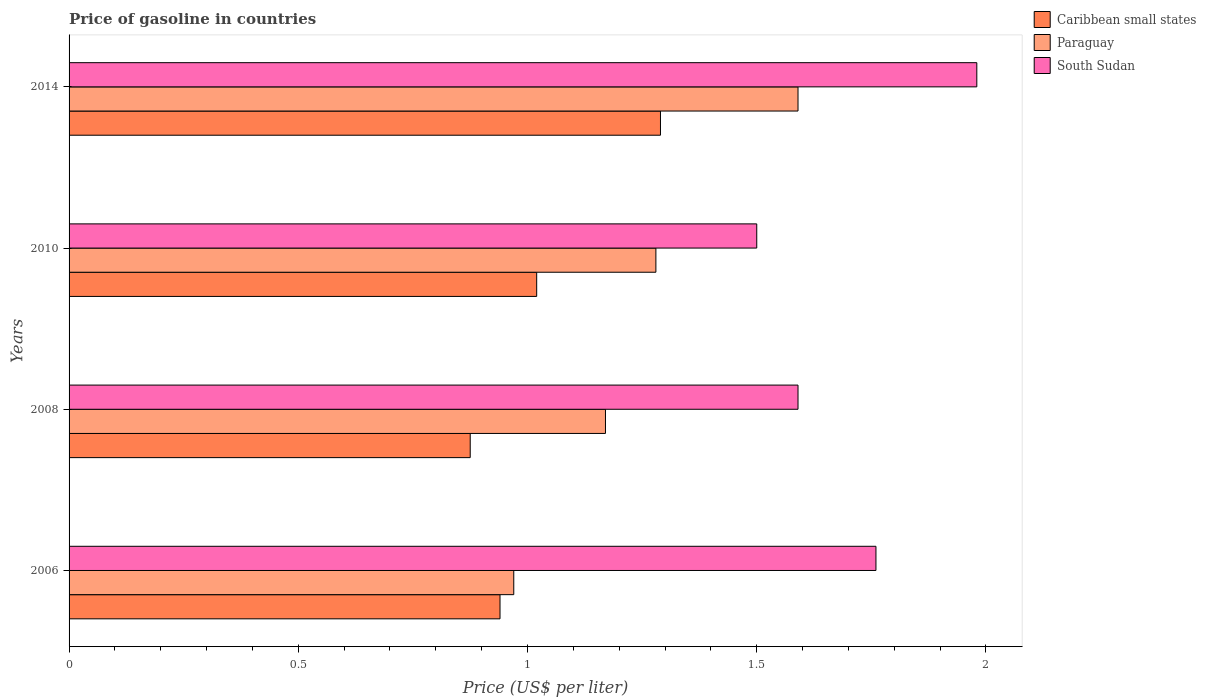How many groups of bars are there?
Give a very brief answer. 4. Are the number of bars on each tick of the Y-axis equal?
Keep it short and to the point. Yes. How many bars are there on the 2nd tick from the top?
Your answer should be very brief. 3. How many bars are there on the 1st tick from the bottom?
Your response must be concise. 3. In how many cases, is the number of bars for a given year not equal to the number of legend labels?
Give a very brief answer. 0. What is the price of gasoline in Paraguay in 2010?
Give a very brief answer. 1.28. Across all years, what is the maximum price of gasoline in South Sudan?
Provide a succinct answer. 1.98. What is the total price of gasoline in Paraguay in the graph?
Your answer should be compact. 5.01. What is the difference between the price of gasoline in South Sudan in 2008 and that in 2010?
Keep it short and to the point. 0.09. What is the difference between the price of gasoline in Caribbean small states in 2010 and the price of gasoline in Paraguay in 2014?
Your response must be concise. -0.57. What is the average price of gasoline in Caribbean small states per year?
Offer a terse response. 1.03. In the year 2006, what is the difference between the price of gasoline in South Sudan and price of gasoline in Caribbean small states?
Offer a very short reply. 0.82. What is the ratio of the price of gasoline in Paraguay in 2010 to that in 2014?
Your answer should be compact. 0.81. What is the difference between the highest and the second highest price of gasoline in South Sudan?
Offer a terse response. 0.22. What is the difference between the highest and the lowest price of gasoline in Caribbean small states?
Keep it short and to the point. 0.42. What does the 3rd bar from the top in 2008 represents?
Provide a short and direct response. Caribbean small states. What does the 1st bar from the bottom in 2006 represents?
Your answer should be compact. Caribbean small states. Is it the case that in every year, the sum of the price of gasoline in Caribbean small states and price of gasoline in South Sudan is greater than the price of gasoline in Paraguay?
Provide a short and direct response. Yes. How many years are there in the graph?
Keep it short and to the point. 4. Are the values on the major ticks of X-axis written in scientific E-notation?
Your response must be concise. No. Does the graph contain any zero values?
Make the answer very short. No. Where does the legend appear in the graph?
Your answer should be compact. Top right. What is the title of the graph?
Make the answer very short. Price of gasoline in countries. Does "Afghanistan" appear as one of the legend labels in the graph?
Provide a succinct answer. No. What is the label or title of the X-axis?
Provide a succinct answer. Price (US$ per liter). What is the label or title of the Y-axis?
Your response must be concise. Years. What is the Price (US$ per liter) of Caribbean small states in 2006?
Make the answer very short. 0.94. What is the Price (US$ per liter) of South Sudan in 2006?
Provide a succinct answer. 1.76. What is the Price (US$ per liter) in Paraguay in 2008?
Provide a succinct answer. 1.17. What is the Price (US$ per liter) in South Sudan in 2008?
Give a very brief answer. 1.59. What is the Price (US$ per liter) in Caribbean small states in 2010?
Your response must be concise. 1.02. What is the Price (US$ per liter) of Paraguay in 2010?
Your answer should be compact. 1.28. What is the Price (US$ per liter) of Caribbean small states in 2014?
Your answer should be very brief. 1.29. What is the Price (US$ per liter) of Paraguay in 2014?
Your answer should be very brief. 1.59. What is the Price (US$ per liter) of South Sudan in 2014?
Offer a terse response. 1.98. Across all years, what is the maximum Price (US$ per liter) of Caribbean small states?
Give a very brief answer. 1.29. Across all years, what is the maximum Price (US$ per liter) of Paraguay?
Offer a very short reply. 1.59. Across all years, what is the maximum Price (US$ per liter) of South Sudan?
Keep it short and to the point. 1.98. Across all years, what is the minimum Price (US$ per liter) of South Sudan?
Keep it short and to the point. 1.5. What is the total Price (US$ per liter) of Caribbean small states in the graph?
Your answer should be compact. 4.12. What is the total Price (US$ per liter) in Paraguay in the graph?
Keep it short and to the point. 5.01. What is the total Price (US$ per liter) of South Sudan in the graph?
Your answer should be compact. 6.83. What is the difference between the Price (US$ per liter) of Caribbean small states in 2006 and that in 2008?
Provide a short and direct response. 0.07. What is the difference between the Price (US$ per liter) of Paraguay in 2006 and that in 2008?
Provide a short and direct response. -0.2. What is the difference between the Price (US$ per liter) of South Sudan in 2006 and that in 2008?
Provide a succinct answer. 0.17. What is the difference between the Price (US$ per liter) in Caribbean small states in 2006 and that in 2010?
Offer a terse response. -0.08. What is the difference between the Price (US$ per liter) in Paraguay in 2006 and that in 2010?
Your response must be concise. -0.31. What is the difference between the Price (US$ per liter) in South Sudan in 2006 and that in 2010?
Keep it short and to the point. 0.26. What is the difference between the Price (US$ per liter) in Caribbean small states in 2006 and that in 2014?
Offer a very short reply. -0.35. What is the difference between the Price (US$ per liter) in Paraguay in 2006 and that in 2014?
Provide a succinct answer. -0.62. What is the difference between the Price (US$ per liter) in South Sudan in 2006 and that in 2014?
Offer a very short reply. -0.22. What is the difference between the Price (US$ per liter) in Caribbean small states in 2008 and that in 2010?
Make the answer very short. -0.14. What is the difference between the Price (US$ per liter) in Paraguay in 2008 and that in 2010?
Make the answer very short. -0.11. What is the difference between the Price (US$ per liter) of South Sudan in 2008 and that in 2010?
Provide a succinct answer. 0.09. What is the difference between the Price (US$ per liter) in Caribbean small states in 2008 and that in 2014?
Provide a succinct answer. -0.41. What is the difference between the Price (US$ per liter) of Paraguay in 2008 and that in 2014?
Ensure brevity in your answer.  -0.42. What is the difference between the Price (US$ per liter) of South Sudan in 2008 and that in 2014?
Ensure brevity in your answer.  -0.39. What is the difference between the Price (US$ per liter) of Caribbean small states in 2010 and that in 2014?
Offer a terse response. -0.27. What is the difference between the Price (US$ per liter) in Paraguay in 2010 and that in 2014?
Your answer should be compact. -0.31. What is the difference between the Price (US$ per liter) of South Sudan in 2010 and that in 2014?
Make the answer very short. -0.48. What is the difference between the Price (US$ per liter) of Caribbean small states in 2006 and the Price (US$ per liter) of Paraguay in 2008?
Keep it short and to the point. -0.23. What is the difference between the Price (US$ per liter) in Caribbean small states in 2006 and the Price (US$ per liter) in South Sudan in 2008?
Keep it short and to the point. -0.65. What is the difference between the Price (US$ per liter) of Paraguay in 2006 and the Price (US$ per liter) of South Sudan in 2008?
Keep it short and to the point. -0.62. What is the difference between the Price (US$ per liter) in Caribbean small states in 2006 and the Price (US$ per liter) in Paraguay in 2010?
Make the answer very short. -0.34. What is the difference between the Price (US$ per liter) of Caribbean small states in 2006 and the Price (US$ per liter) of South Sudan in 2010?
Your answer should be compact. -0.56. What is the difference between the Price (US$ per liter) in Paraguay in 2006 and the Price (US$ per liter) in South Sudan in 2010?
Your answer should be very brief. -0.53. What is the difference between the Price (US$ per liter) of Caribbean small states in 2006 and the Price (US$ per liter) of Paraguay in 2014?
Give a very brief answer. -0.65. What is the difference between the Price (US$ per liter) in Caribbean small states in 2006 and the Price (US$ per liter) in South Sudan in 2014?
Your answer should be compact. -1.04. What is the difference between the Price (US$ per liter) in Paraguay in 2006 and the Price (US$ per liter) in South Sudan in 2014?
Provide a succinct answer. -1.01. What is the difference between the Price (US$ per liter) in Caribbean small states in 2008 and the Price (US$ per liter) in Paraguay in 2010?
Offer a very short reply. -0.41. What is the difference between the Price (US$ per liter) in Caribbean small states in 2008 and the Price (US$ per liter) in South Sudan in 2010?
Ensure brevity in your answer.  -0.62. What is the difference between the Price (US$ per liter) of Paraguay in 2008 and the Price (US$ per liter) of South Sudan in 2010?
Provide a succinct answer. -0.33. What is the difference between the Price (US$ per liter) in Caribbean small states in 2008 and the Price (US$ per liter) in Paraguay in 2014?
Your answer should be compact. -0.71. What is the difference between the Price (US$ per liter) in Caribbean small states in 2008 and the Price (US$ per liter) in South Sudan in 2014?
Provide a short and direct response. -1.1. What is the difference between the Price (US$ per liter) in Paraguay in 2008 and the Price (US$ per liter) in South Sudan in 2014?
Offer a very short reply. -0.81. What is the difference between the Price (US$ per liter) in Caribbean small states in 2010 and the Price (US$ per liter) in Paraguay in 2014?
Your response must be concise. -0.57. What is the difference between the Price (US$ per liter) in Caribbean small states in 2010 and the Price (US$ per liter) in South Sudan in 2014?
Give a very brief answer. -0.96. What is the difference between the Price (US$ per liter) in Paraguay in 2010 and the Price (US$ per liter) in South Sudan in 2014?
Your answer should be compact. -0.7. What is the average Price (US$ per liter) of Caribbean small states per year?
Make the answer very short. 1.03. What is the average Price (US$ per liter) in Paraguay per year?
Provide a succinct answer. 1.25. What is the average Price (US$ per liter) of South Sudan per year?
Offer a very short reply. 1.71. In the year 2006, what is the difference between the Price (US$ per liter) in Caribbean small states and Price (US$ per liter) in Paraguay?
Offer a terse response. -0.03. In the year 2006, what is the difference between the Price (US$ per liter) of Caribbean small states and Price (US$ per liter) of South Sudan?
Make the answer very short. -0.82. In the year 2006, what is the difference between the Price (US$ per liter) in Paraguay and Price (US$ per liter) in South Sudan?
Give a very brief answer. -0.79. In the year 2008, what is the difference between the Price (US$ per liter) in Caribbean small states and Price (US$ per liter) in Paraguay?
Ensure brevity in your answer.  -0.29. In the year 2008, what is the difference between the Price (US$ per liter) of Caribbean small states and Price (US$ per liter) of South Sudan?
Offer a very short reply. -0.71. In the year 2008, what is the difference between the Price (US$ per liter) in Paraguay and Price (US$ per liter) in South Sudan?
Keep it short and to the point. -0.42. In the year 2010, what is the difference between the Price (US$ per liter) in Caribbean small states and Price (US$ per liter) in Paraguay?
Provide a succinct answer. -0.26. In the year 2010, what is the difference between the Price (US$ per liter) of Caribbean small states and Price (US$ per liter) of South Sudan?
Offer a terse response. -0.48. In the year 2010, what is the difference between the Price (US$ per liter) in Paraguay and Price (US$ per liter) in South Sudan?
Provide a succinct answer. -0.22. In the year 2014, what is the difference between the Price (US$ per liter) of Caribbean small states and Price (US$ per liter) of South Sudan?
Give a very brief answer. -0.69. In the year 2014, what is the difference between the Price (US$ per liter) in Paraguay and Price (US$ per liter) in South Sudan?
Provide a succinct answer. -0.39. What is the ratio of the Price (US$ per liter) in Caribbean small states in 2006 to that in 2008?
Provide a succinct answer. 1.07. What is the ratio of the Price (US$ per liter) in Paraguay in 2006 to that in 2008?
Offer a terse response. 0.83. What is the ratio of the Price (US$ per liter) of South Sudan in 2006 to that in 2008?
Your answer should be compact. 1.11. What is the ratio of the Price (US$ per liter) of Caribbean small states in 2006 to that in 2010?
Offer a very short reply. 0.92. What is the ratio of the Price (US$ per liter) of Paraguay in 2006 to that in 2010?
Make the answer very short. 0.76. What is the ratio of the Price (US$ per liter) of South Sudan in 2006 to that in 2010?
Give a very brief answer. 1.17. What is the ratio of the Price (US$ per liter) of Caribbean small states in 2006 to that in 2014?
Provide a short and direct response. 0.73. What is the ratio of the Price (US$ per liter) in Paraguay in 2006 to that in 2014?
Give a very brief answer. 0.61. What is the ratio of the Price (US$ per liter) in South Sudan in 2006 to that in 2014?
Give a very brief answer. 0.89. What is the ratio of the Price (US$ per liter) of Caribbean small states in 2008 to that in 2010?
Your response must be concise. 0.86. What is the ratio of the Price (US$ per liter) of Paraguay in 2008 to that in 2010?
Your answer should be very brief. 0.91. What is the ratio of the Price (US$ per liter) in South Sudan in 2008 to that in 2010?
Your answer should be very brief. 1.06. What is the ratio of the Price (US$ per liter) in Caribbean small states in 2008 to that in 2014?
Make the answer very short. 0.68. What is the ratio of the Price (US$ per liter) in Paraguay in 2008 to that in 2014?
Provide a short and direct response. 0.74. What is the ratio of the Price (US$ per liter) of South Sudan in 2008 to that in 2014?
Provide a short and direct response. 0.8. What is the ratio of the Price (US$ per liter) of Caribbean small states in 2010 to that in 2014?
Offer a very short reply. 0.79. What is the ratio of the Price (US$ per liter) in Paraguay in 2010 to that in 2014?
Make the answer very short. 0.81. What is the ratio of the Price (US$ per liter) of South Sudan in 2010 to that in 2014?
Ensure brevity in your answer.  0.76. What is the difference between the highest and the second highest Price (US$ per liter) in Caribbean small states?
Provide a succinct answer. 0.27. What is the difference between the highest and the second highest Price (US$ per liter) of Paraguay?
Offer a terse response. 0.31. What is the difference between the highest and the second highest Price (US$ per liter) in South Sudan?
Your answer should be compact. 0.22. What is the difference between the highest and the lowest Price (US$ per liter) in Caribbean small states?
Your response must be concise. 0.41. What is the difference between the highest and the lowest Price (US$ per liter) of Paraguay?
Ensure brevity in your answer.  0.62. What is the difference between the highest and the lowest Price (US$ per liter) in South Sudan?
Make the answer very short. 0.48. 